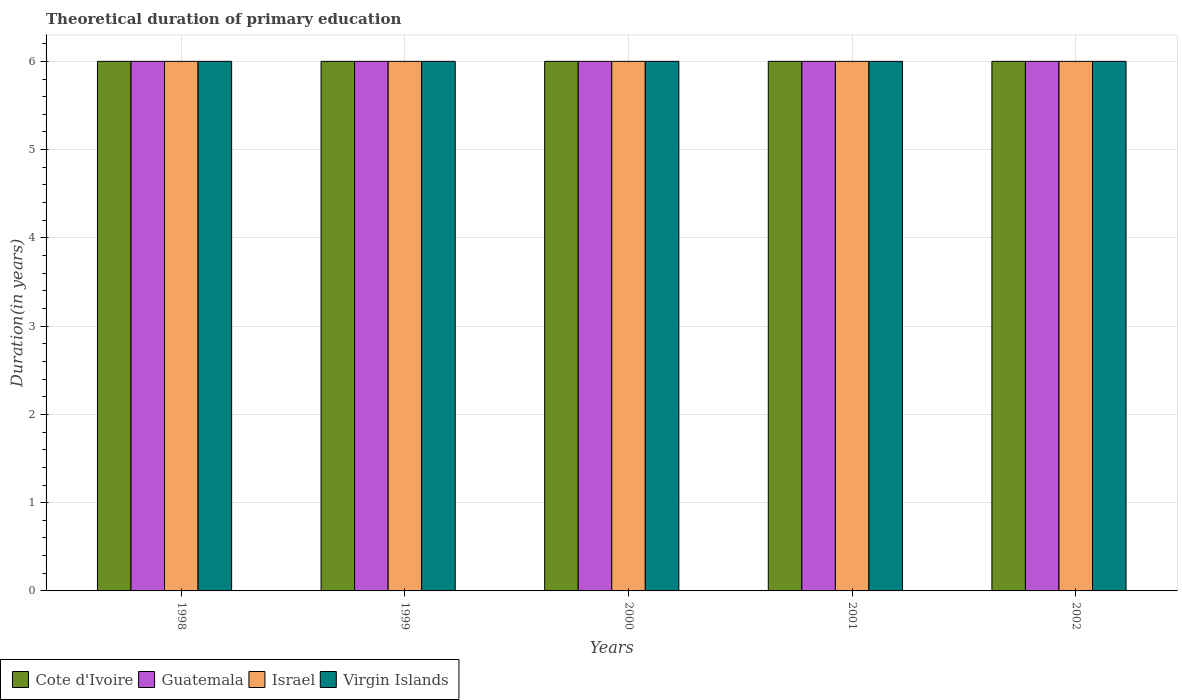How many different coloured bars are there?
Provide a short and direct response. 4. Are the number of bars on each tick of the X-axis equal?
Your response must be concise. Yes. How many bars are there on the 5th tick from the left?
Provide a short and direct response. 4. What is the total theoretical duration of primary education in Virgin Islands in 1999?
Your answer should be compact. 6. In which year was the total theoretical duration of primary education in Virgin Islands minimum?
Your response must be concise. 1998. What is the total total theoretical duration of primary education in Cote d'Ivoire in the graph?
Make the answer very short. 30. What is the difference between the total theoretical duration of primary education in Israel in 1998 and the total theoretical duration of primary education in Virgin Islands in 1999?
Your response must be concise. 0. What is the average total theoretical duration of primary education in Virgin Islands per year?
Provide a short and direct response. 6. In the year 1999, what is the difference between the total theoretical duration of primary education in Virgin Islands and total theoretical duration of primary education in Guatemala?
Provide a short and direct response. 0. In how many years, is the total theoretical duration of primary education in Virgin Islands greater than 1 years?
Your response must be concise. 5. What is the ratio of the total theoretical duration of primary education in Cote d'Ivoire in 2000 to that in 2002?
Your answer should be very brief. 1. Is the total theoretical duration of primary education in Cote d'Ivoire in 2000 less than that in 2002?
Offer a very short reply. No. Is the difference between the total theoretical duration of primary education in Virgin Islands in 2000 and 2002 greater than the difference between the total theoretical duration of primary education in Guatemala in 2000 and 2002?
Ensure brevity in your answer.  No. What is the difference between the highest and the lowest total theoretical duration of primary education in Guatemala?
Your answer should be compact. 0. Is it the case that in every year, the sum of the total theoretical duration of primary education in Israel and total theoretical duration of primary education in Virgin Islands is greater than the sum of total theoretical duration of primary education in Cote d'Ivoire and total theoretical duration of primary education in Guatemala?
Make the answer very short. No. What does the 1st bar from the left in 1999 represents?
Keep it short and to the point. Cote d'Ivoire. What does the 4th bar from the right in 1999 represents?
Your answer should be very brief. Cote d'Ivoire. How many bars are there?
Provide a short and direct response. 20. Are all the bars in the graph horizontal?
Your response must be concise. No. What is the difference between two consecutive major ticks on the Y-axis?
Offer a terse response. 1. Where does the legend appear in the graph?
Offer a terse response. Bottom left. How are the legend labels stacked?
Your answer should be very brief. Horizontal. What is the title of the graph?
Offer a terse response. Theoretical duration of primary education. Does "Germany" appear as one of the legend labels in the graph?
Provide a short and direct response. No. What is the label or title of the X-axis?
Keep it short and to the point. Years. What is the label or title of the Y-axis?
Make the answer very short. Duration(in years). What is the Duration(in years) of Cote d'Ivoire in 1998?
Keep it short and to the point. 6. What is the Duration(in years) in Virgin Islands in 1998?
Keep it short and to the point. 6. What is the Duration(in years) in Cote d'Ivoire in 1999?
Offer a very short reply. 6. What is the Duration(in years) of Guatemala in 1999?
Offer a terse response. 6. What is the Duration(in years) in Israel in 1999?
Ensure brevity in your answer.  6. What is the Duration(in years) of Virgin Islands in 2000?
Offer a very short reply. 6. What is the Duration(in years) in Cote d'Ivoire in 2002?
Your answer should be compact. 6. What is the Duration(in years) of Israel in 2002?
Offer a very short reply. 6. What is the Duration(in years) in Virgin Islands in 2002?
Make the answer very short. 6. Across all years, what is the maximum Duration(in years) of Cote d'Ivoire?
Offer a very short reply. 6. Across all years, what is the maximum Duration(in years) of Guatemala?
Provide a short and direct response. 6. Across all years, what is the maximum Duration(in years) in Virgin Islands?
Provide a succinct answer. 6. Across all years, what is the minimum Duration(in years) in Israel?
Provide a short and direct response. 6. Across all years, what is the minimum Duration(in years) of Virgin Islands?
Offer a very short reply. 6. What is the total Duration(in years) in Guatemala in the graph?
Make the answer very short. 30. What is the difference between the Duration(in years) in Guatemala in 1998 and that in 1999?
Offer a terse response. 0. What is the difference between the Duration(in years) of Cote d'Ivoire in 1998 and that in 2000?
Your answer should be compact. 0. What is the difference between the Duration(in years) of Guatemala in 1998 and that in 2000?
Offer a terse response. 0. What is the difference between the Duration(in years) in Cote d'Ivoire in 1998 and that in 2001?
Make the answer very short. 0. What is the difference between the Duration(in years) in Guatemala in 1998 and that in 2001?
Offer a very short reply. 0. What is the difference between the Duration(in years) of Israel in 1998 and that in 2001?
Your answer should be very brief. 0. What is the difference between the Duration(in years) of Virgin Islands in 1998 and that in 2001?
Give a very brief answer. 0. What is the difference between the Duration(in years) of Cote d'Ivoire in 1998 and that in 2002?
Your answer should be compact. 0. What is the difference between the Duration(in years) in Israel in 1998 and that in 2002?
Ensure brevity in your answer.  0. What is the difference between the Duration(in years) of Cote d'Ivoire in 1999 and that in 2001?
Make the answer very short. 0. What is the difference between the Duration(in years) in Guatemala in 1999 and that in 2002?
Your response must be concise. 0. What is the difference between the Duration(in years) in Guatemala in 2000 and that in 2001?
Ensure brevity in your answer.  0. What is the difference between the Duration(in years) of Virgin Islands in 2000 and that in 2001?
Provide a short and direct response. 0. What is the difference between the Duration(in years) of Cote d'Ivoire in 2000 and that in 2002?
Provide a succinct answer. 0. What is the difference between the Duration(in years) in Guatemala in 2000 and that in 2002?
Provide a short and direct response. 0. What is the difference between the Duration(in years) of Virgin Islands in 2000 and that in 2002?
Your answer should be very brief. 0. What is the difference between the Duration(in years) in Israel in 2001 and that in 2002?
Offer a terse response. 0. What is the difference between the Duration(in years) of Guatemala in 1998 and the Duration(in years) of Israel in 1999?
Provide a short and direct response. 0. What is the difference between the Duration(in years) of Guatemala in 1998 and the Duration(in years) of Virgin Islands in 1999?
Your answer should be very brief. 0. What is the difference between the Duration(in years) in Israel in 1998 and the Duration(in years) in Virgin Islands in 1999?
Ensure brevity in your answer.  0. What is the difference between the Duration(in years) of Cote d'Ivoire in 1998 and the Duration(in years) of Virgin Islands in 2000?
Your answer should be compact. 0. What is the difference between the Duration(in years) in Guatemala in 1998 and the Duration(in years) in Israel in 2000?
Keep it short and to the point. 0. What is the difference between the Duration(in years) in Cote d'Ivoire in 1998 and the Duration(in years) in Virgin Islands in 2001?
Your answer should be compact. 0. What is the difference between the Duration(in years) of Guatemala in 1998 and the Duration(in years) of Israel in 2001?
Ensure brevity in your answer.  0. What is the difference between the Duration(in years) of Israel in 1998 and the Duration(in years) of Virgin Islands in 2001?
Make the answer very short. 0. What is the difference between the Duration(in years) of Israel in 1998 and the Duration(in years) of Virgin Islands in 2002?
Offer a terse response. 0. What is the difference between the Duration(in years) in Cote d'Ivoire in 1999 and the Duration(in years) in Guatemala in 2000?
Give a very brief answer. 0. What is the difference between the Duration(in years) in Cote d'Ivoire in 1999 and the Duration(in years) in Virgin Islands in 2000?
Offer a very short reply. 0. What is the difference between the Duration(in years) of Guatemala in 1999 and the Duration(in years) of Virgin Islands in 2000?
Your answer should be very brief. 0. What is the difference between the Duration(in years) in Israel in 1999 and the Duration(in years) in Virgin Islands in 2000?
Your answer should be very brief. 0. What is the difference between the Duration(in years) of Cote d'Ivoire in 1999 and the Duration(in years) of Guatemala in 2001?
Provide a short and direct response. 0. What is the difference between the Duration(in years) in Cote d'Ivoire in 1999 and the Duration(in years) in Guatemala in 2002?
Offer a terse response. 0. What is the difference between the Duration(in years) of Cote d'Ivoire in 1999 and the Duration(in years) of Israel in 2002?
Your answer should be compact. 0. What is the difference between the Duration(in years) of Guatemala in 1999 and the Duration(in years) of Israel in 2002?
Make the answer very short. 0. What is the difference between the Duration(in years) in Israel in 1999 and the Duration(in years) in Virgin Islands in 2002?
Your answer should be very brief. 0. What is the difference between the Duration(in years) of Cote d'Ivoire in 2000 and the Duration(in years) of Guatemala in 2001?
Offer a terse response. 0. What is the difference between the Duration(in years) of Cote d'Ivoire in 2000 and the Duration(in years) of Israel in 2001?
Ensure brevity in your answer.  0. What is the difference between the Duration(in years) in Cote d'Ivoire in 2000 and the Duration(in years) in Virgin Islands in 2001?
Offer a very short reply. 0. What is the difference between the Duration(in years) in Guatemala in 2000 and the Duration(in years) in Israel in 2001?
Your response must be concise. 0. What is the difference between the Duration(in years) of Guatemala in 2000 and the Duration(in years) of Virgin Islands in 2001?
Provide a short and direct response. 0. What is the difference between the Duration(in years) of Cote d'Ivoire in 2000 and the Duration(in years) of Guatemala in 2002?
Provide a short and direct response. 0. What is the difference between the Duration(in years) in Cote d'Ivoire in 2000 and the Duration(in years) in Israel in 2002?
Offer a very short reply. 0. What is the difference between the Duration(in years) in Cote d'Ivoire in 2000 and the Duration(in years) in Virgin Islands in 2002?
Give a very brief answer. 0. What is the difference between the Duration(in years) of Cote d'Ivoire in 2001 and the Duration(in years) of Guatemala in 2002?
Provide a short and direct response. 0. What is the difference between the Duration(in years) in Guatemala in 2001 and the Duration(in years) in Virgin Islands in 2002?
Ensure brevity in your answer.  0. What is the average Duration(in years) of Cote d'Ivoire per year?
Offer a terse response. 6. What is the average Duration(in years) in Guatemala per year?
Keep it short and to the point. 6. What is the average Duration(in years) in Israel per year?
Your answer should be very brief. 6. In the year 1998, what is the difference between the Duration(in years) in Cote d'Ivoire and Duration(in years) in Guatemala?
Provide a succinct answer. 0. In the year 1998, what is the difference between the Duration(in years) in Cote d'Ivoire and Duration(in years) in Virgin Islands?
Your answer should be very brief. 0. In the year 1998, what is the difference between the Duration(in years) of Israel and Duration(in years) of Virgin Islands?
Your response must be concise. 0. In the year 1999, what is the difference between the Duration(in years) of Cote d'Ivoire and Duration(in years) of Virgin Islands?
Ensure brevity in your answer.  0. In the year 1999, what is the difference between the Duration(in years) of Guatemala and Duration(in years) of Israel?
Ensure brevity in your answer.  0. In the year 2000, what is the difference between the Duration(in years) of Cote d'Ivoire and Duration(in years) of Guatemala?
Offer a terse response. 0. In the year 2000, what is the difference between the Duration(in years) of Cote d'Ivoire and Duration(in years) of Israel?
Ensure brevity in your answer.  0. In the year 2000, what is the difference between the Duration(in years) of Guatemala and Duration(in years) of Israel?
Provide a succinct answer. 0. In the year 2000, what is the difference between the Duration(in years) of Guatemala and Duration(in years) of Virgin Islands?
Your answer should be compact. 0. In the year 2001, what is the difference between the Duration(in years) in Cote d'Ivoire and Duration(in years) in Guatemala?
Provide a short and direct response. 0. In the year 2001, what is the difference between the Duration(in years) of Cote d'Ivoire and Duration(in years) of Virgin Islands?
Provide a succinct answer. 0. In the year 2002, what is the difference between the Duration(in years) in Cote d'Ivoire and Duration(in years) in Guatemala?
Keep it short and to the point. 0. In the year 2002, what is the difference between the Duration(in years) in Cote d'Ivoire and Duration(in years) in Israel?
Keep it short and to the point. 0. In the year 2002, what is the difference between the Duration(in years) in Cote d'Ivoire and Duration(in years) in Virgin Islands?
Offer a terse response. 0. In the year 2002, what is the difference between the Duration(in years) of Guatemala and Duration(in years) of Israel?
Make the answer very short. 0. In the year 2002, what is the difference between the Duration(in years) of Israel and Duration(in years) of Virgin Islands?
Provide a succinct answer. 0. What is the ratio of the Duration(in years) in Guatemala in 1998 to that in 1999?
Provide a short and direct response. 1. What is the ratio of the Duration(in years) of Virgin Islands in 1998 to that in 1999?
Your answer should be compact. 1. What is the ratio of the Duration(in years) in Cote d'Ivoire in 1998 to that in 2000?
Your response must be concise. 1. What is the ratio of the Duration(in years) in Guatemala in 1998 to that in 2000?
Give a very brief answer. 1. What is the ratio of the Duration(in years) of Cote d'Ivoire in 1998 to that in 2001?
Give a very brief answer. 1. What is the ratio of the Duration(in years) in Guatemala in 1998 to that in 2001?
Give a very brief answer. 1. What is the ratio of the Duration(in years) in Virgin Islands in 1998 to that in 2001?
Provide a succinct answer. 1. What is the ratio of the Duration(in years) of Cote d'Ivoire in 1998 to that in 2002?
Your answer should be very brief. 1. What is the ratio of the Duration(in years) in Israel in 1998 to that in 2002?
Offer a terse response. 1. What is the ratio of the Duration(in years) in Cote d'Ivoire in 1999 to that in 2000?
Give a very brief answer. 1. What is the ratio of the Duration(in years) of Guatemala in 1999 to that in 2000?
Provide a succinct answer. 1. What is the ratio of the Duration(in years) in Virgin Islands in 1999 to that in 2000?
Offer a terse response. 1. What is the ratio of the Duration(in years) in Cote d'Ivoire in 1999 to that in 2001?
Provide a succinct answer. 1. What is the ratio of the Duration(in years) in Guatemala in 1999 to that in 2001?
Give a very brief answer. 1. What is the ratio of the Duration(in years) in Israel in 1999 to that in 2001?
Ensure brevity in your answer.  1. What is the ratio of the Duration(in years) in Virgin Islands in 1999 to that in 2002?
Provide a short and direct response. 1. What is the ratio of the Duration(in years) of Cote d'Ivoire in 2000 to that in 2001?
Offer a very short reply. 1. What is the ratio of the Duration(in years) of Israel in 2000 to that in 2001?
Make the answer very short. 1. What is the ratio of the Duration(in years) of Virgin Islands in 2000 to that in 2001?
Give a very brief answer. 1. What is the ratio of the Duration(in years) in Cote d'Ivoire in 2001 to that in 2002?
Offer a very short reply. 1. What is the ratio of the Duration(in years) in Guatemala in 2001 to that in 2002?
Your answer should be compact. 1. What is the ratio of the Duration(in years) of Virgin Islands in 2001 to that in 2002?
Your answer should be compact. 1. What is the difference between the highest and the second highest Duration(in years) of Israel?
Give a very brief answer. 0. What is the difference between the highest and the lowest Duration(in years) in Cote d'Ivoire?
Your answer should be compact. 0. What is the difference between the highest and the lowest Duration(in years) in Virgin Islands?
Offer a very short reply. 0. 